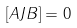<formula> <loc_0><loc_0><loc_500><loc_500>[ A J B ] = 0</formula> 